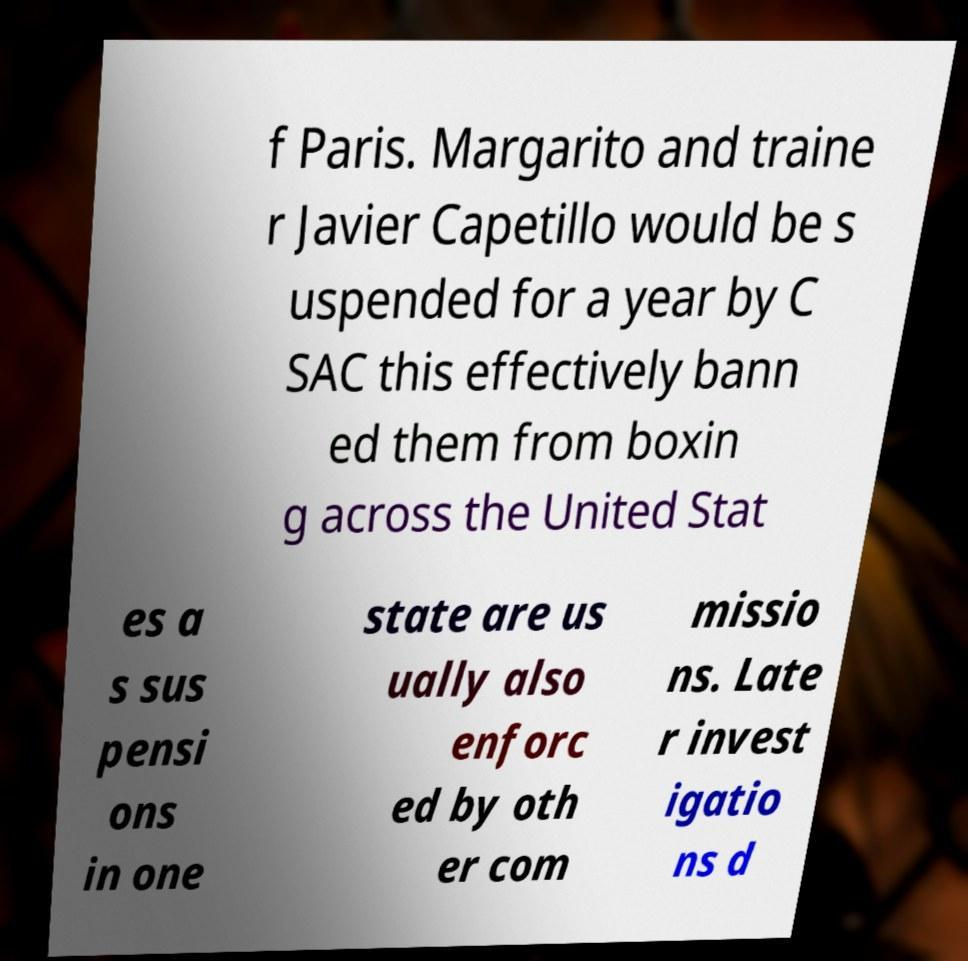Could you extract and type out the text from this image? f Paris. Margarito and traine r Javier Capetillo would be s uspended for a year by C SAC this effectively bann ed them from boxin g across the United Stat es a s sus pensi ons in one state are us ually also enforc ed by oth er com missio ns. Late r invest igatio ns d 